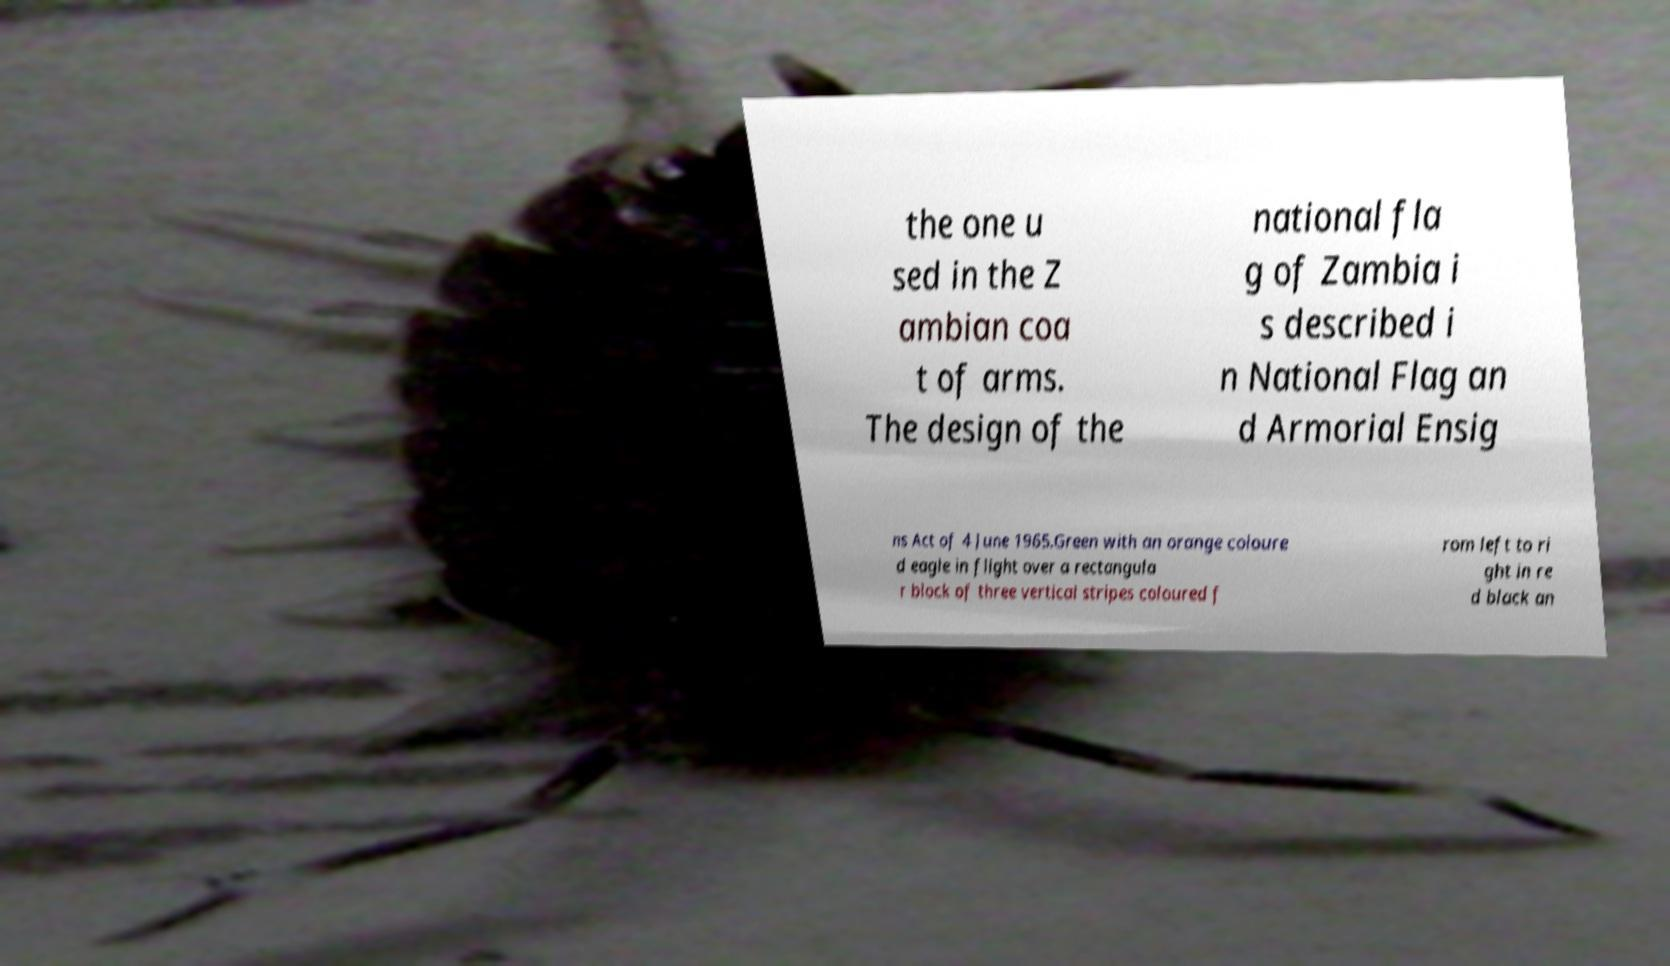Please identify and transcribe the text found in this image. the one u sed in the Z ambian coa t of arms. The design of the national fla g of Zambia i s described i n National Flag an d Armorial Ensig ns Act of 4 June 1965.Green with an orange coloure d eagle in flight over a rectangula r block of three vertical stripes coloured f rom left to ri ght in re d black an 